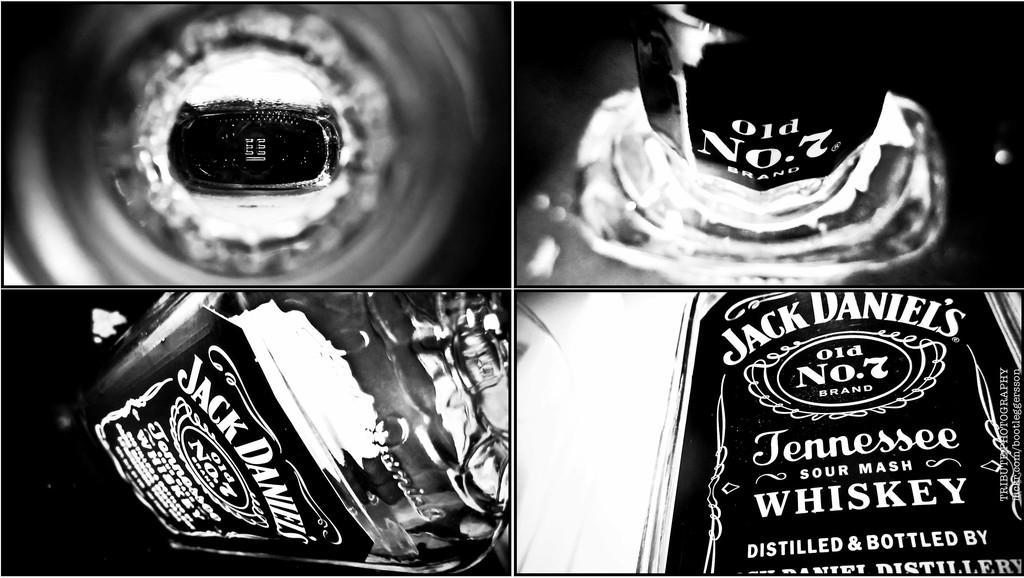In one or two sentences, can you explain what this image depicts? This is a wine bottle and it is collage edited image. 